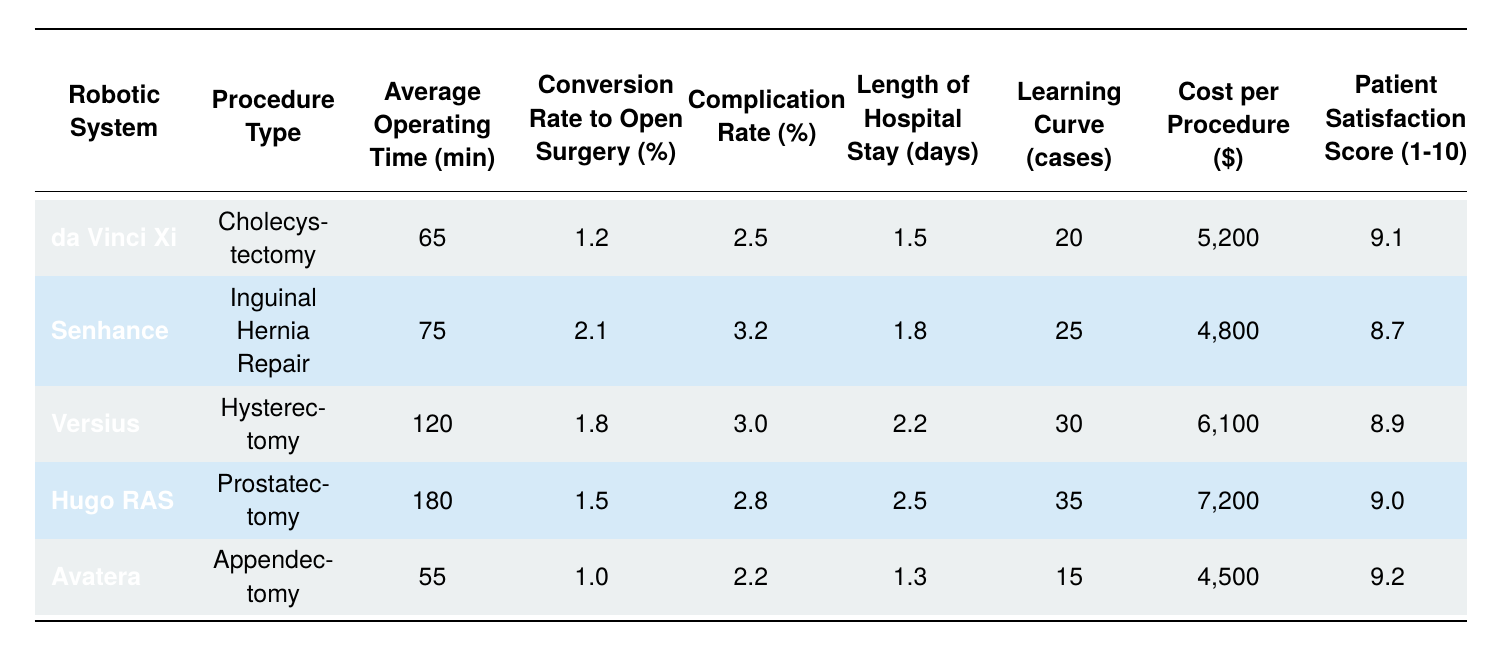What is the average operating time for the da Vinci Xi system? The table lists the average operating time for the da Vinci Xi system as 65 minutes.
Answer: 65 minutes Which robotic system has the lowest complication rate? By comparing the complication rates listed, the Avatera system has the lowest rate at 2.2%.
Answer: Avatera What is the learning curve in cases for the procedure with the highest average operating time? The procedure with the highest average operating time is Prostatectomy performed by Hugo RAS, which has a learning curve of 35 cases.
Answer: 35 cases Is the average cost per procedure for the Senhance higher than for the Avatera? The cost per procedure for Senhance is $4800, while for Avatera it is $4500. Since $4800 is greater than $4500, the statement is true.
Answer: Yes What is the total average operating time for all procedures listed? The average operating times are as follows: 65 (da Vinci Xi) + 75 (Senhance) + 120 (Versius) + 180 (Hugo RAS) + 55 (Avatera) = 495 minutes. Therefore, the total average operating time for all procedures is 495 minutes.
Answer: 495 minutes Which robotic system has the highest patient satisfaction score, and what is the score? The da Vinci Xi system has a patient satisfaction score of 9.1, which is the highest compared to the others listed.
Answer: 9.1 What is the average length of hospital stay for the procedures listed? The lengths of hospital stays are: 1.5 (da Vinci Xi) + 1.8 (Senhance) + 2.2 (Versius) + 2.5 (Hugo RAS) + 1.3 (Avatera) = 9.3 days total. Dividing by 5 procedures gives an average of 1.86 days.
Answer: 1.86 days How does the conversion rate to open surgery for the Hugo RAS compare to the Versius? The conversion rate for Hugo RAS is 1.5%, while for Versius it is 1.8%. Since 1.5% is less than 1.8%, the conversion rate for Hugo RAS is lower.
Answer: Lower Is the average operating time for inguinal hernia repair longer than for appendectomy? The average operating time for inguinal hernia repair using Senhance is 75 minutes, while for appendectomy using Avatera it is 55 minutes. Since 75 minutes is greater than 55 minutes, the statement is true.
Answer: Yes 